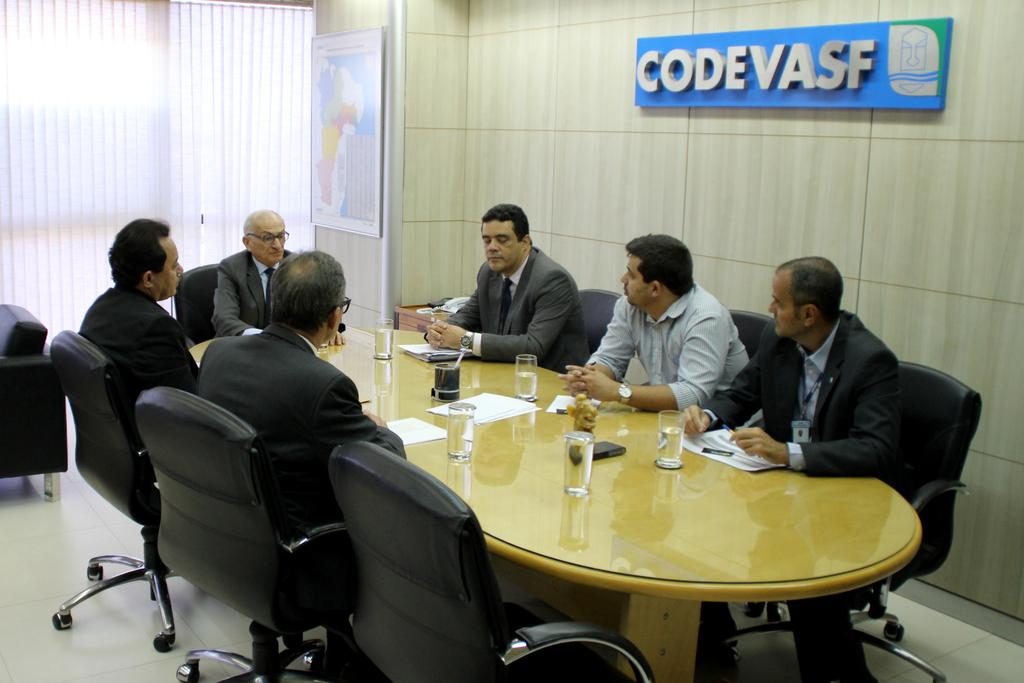<image>
Render a clear and concise summary of the photo. A group of men sit around a conference table in a room with the sign, "CODEVASF." 